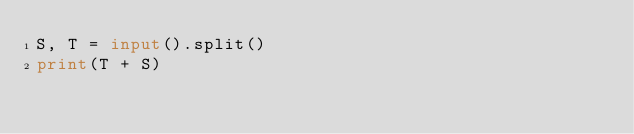Convert code to text. <code><loc_0><loc_0><loc_500><loc_500><_Python_>S, T = input().split()
print(T + S)</code> 